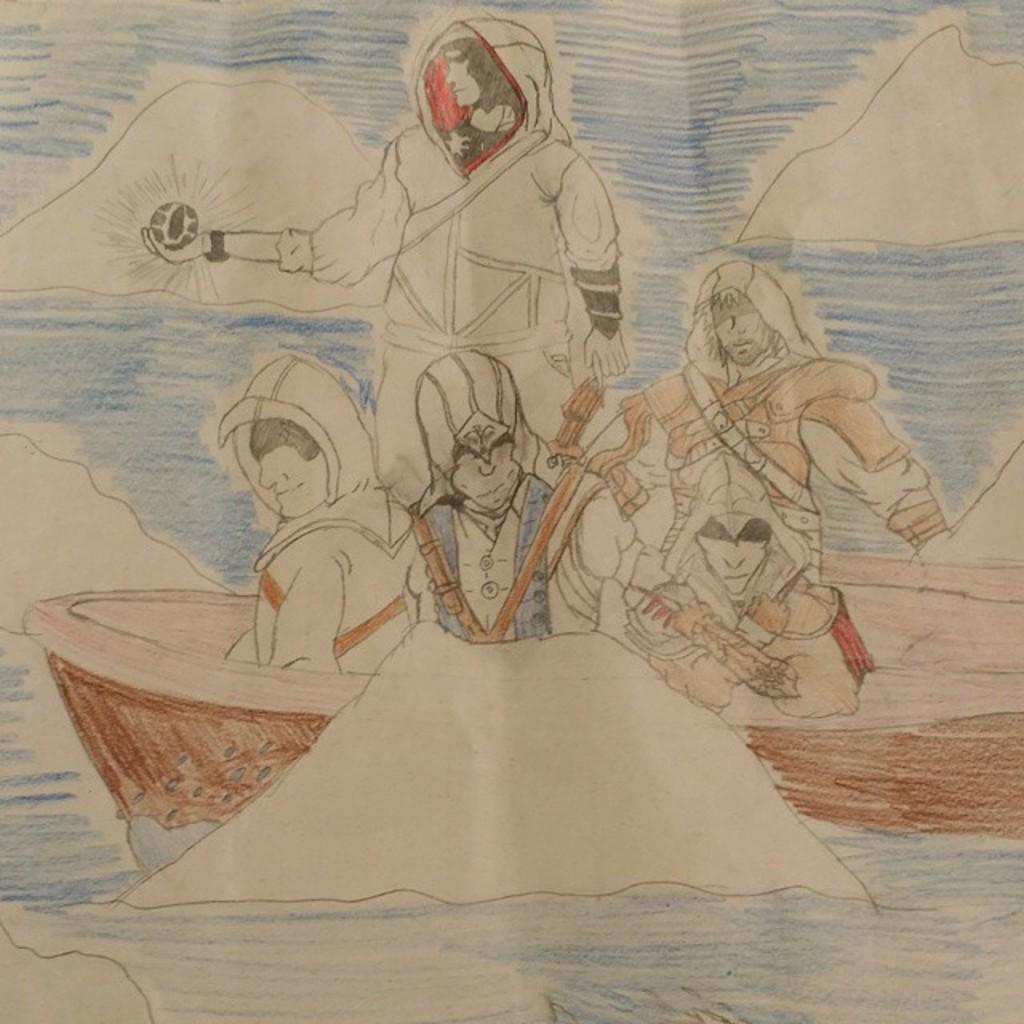Please provide a concise description of this image. The picture is a drawing art. In this picture there are few people in a boat like object 